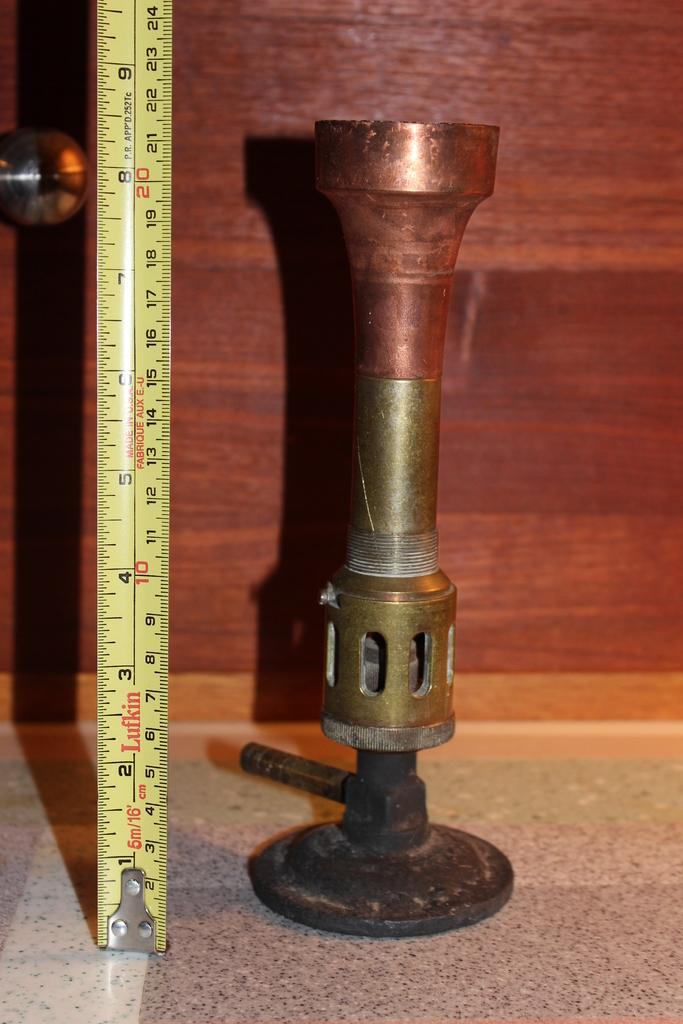Provide a one-sentence caption for the provided image. A Lufkin tape measure is stretched out measuring a metal object. 